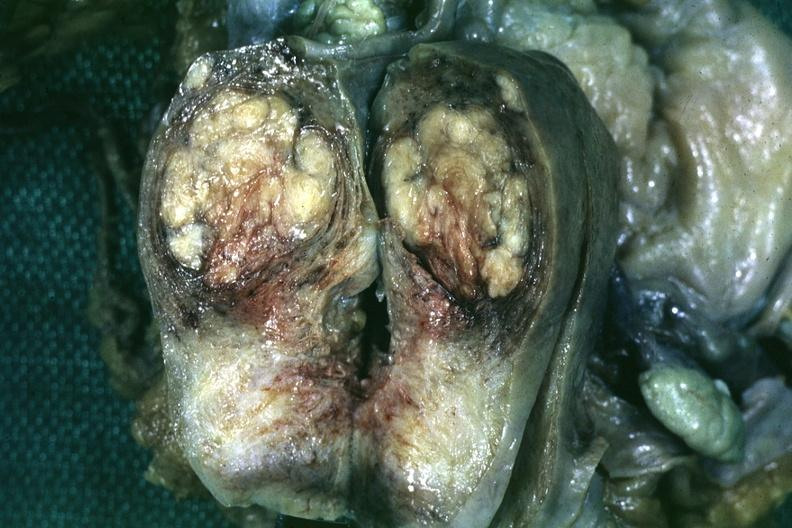does lesion of myocytolysis show fixed tissue saggital section of organ with bosselated myoma?
Answer the question using a single word or phrase. No 